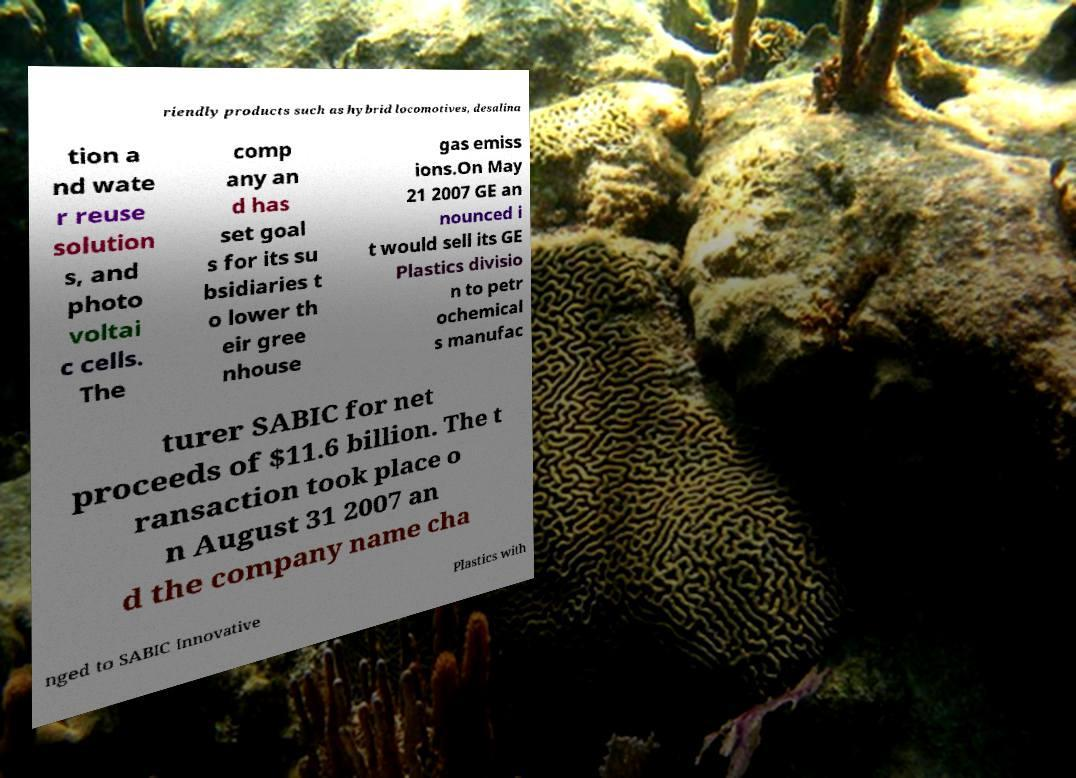Can you read and provide the text displayed in the image?This photo seems to have some interesting text. Can you extract and type it out for me? riendly products such as hybrid locomotives, desalina tion a nd wate r reuse solution s, and photo voltai c cells. The comp any an d has set goal s for its su bsidiaries t o lower th eir gree nhouse gas emiss ions.On May 21 2007 GE an nounced i t would sell its GE Plastics divisio n to petr ochemical s manufac turer SABIC for net proceeds of $11.6 billion. The t ransaction took place o n August 31 2007 an d the company name cha nged to SABIC Innovative Plastics with 